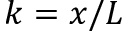Convert formula to latex. <formula><loc_0><loc_0><loc_500><loc_500>k = x / L</formula> 